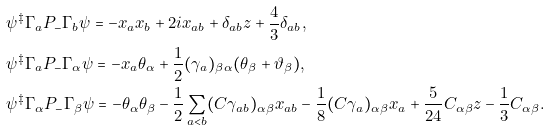Convert formula to latex. <formula><loc_0><loc_0><loc_500><loc_500>& \psi ^ { \ddagger } \Gamma _ { a } P _ { - } \Gamma _ { b } \psi = - x _ { a } x _ { b } + 2 i x _ { a b } + \delta _ { a b } z + \frac { 4 } { 3 } \delta _ { a b } , \\ & \psi ^ { \ddagger } \Gamma _ { a } P _ { - } \Gamma _ { \alpha } \psi = - x _ { a } \theta _ { \alpha } + \frac { 1 } { 2 } ( \gamma _ { a } ) _ { \beta \alpha } ( \theta _ { \beta } + \vartheta _ { \beta } ) , \\ & \psi ^ { \ddagger } \Gamma _ { \alpha } P _ { - } \Gamma _ { \beta } \psi = - \theta _ { \alpha } \theta _ { \beta } - \frac { 1 } { 2 } \sum _ { a < b } ( C \gamma _ { a b } ) _ { \alpha \beta } x _ { a b } - \frac { 1 } { 8 } ( C \gamma _ { a } ) _ { \alpha \beta } x _ { a } + \frac { 5 } { 2 4 } C _ { \alpha \beta } z - \frac { 1 } { 3 } C _ { \alpha \beta } .</formula> 